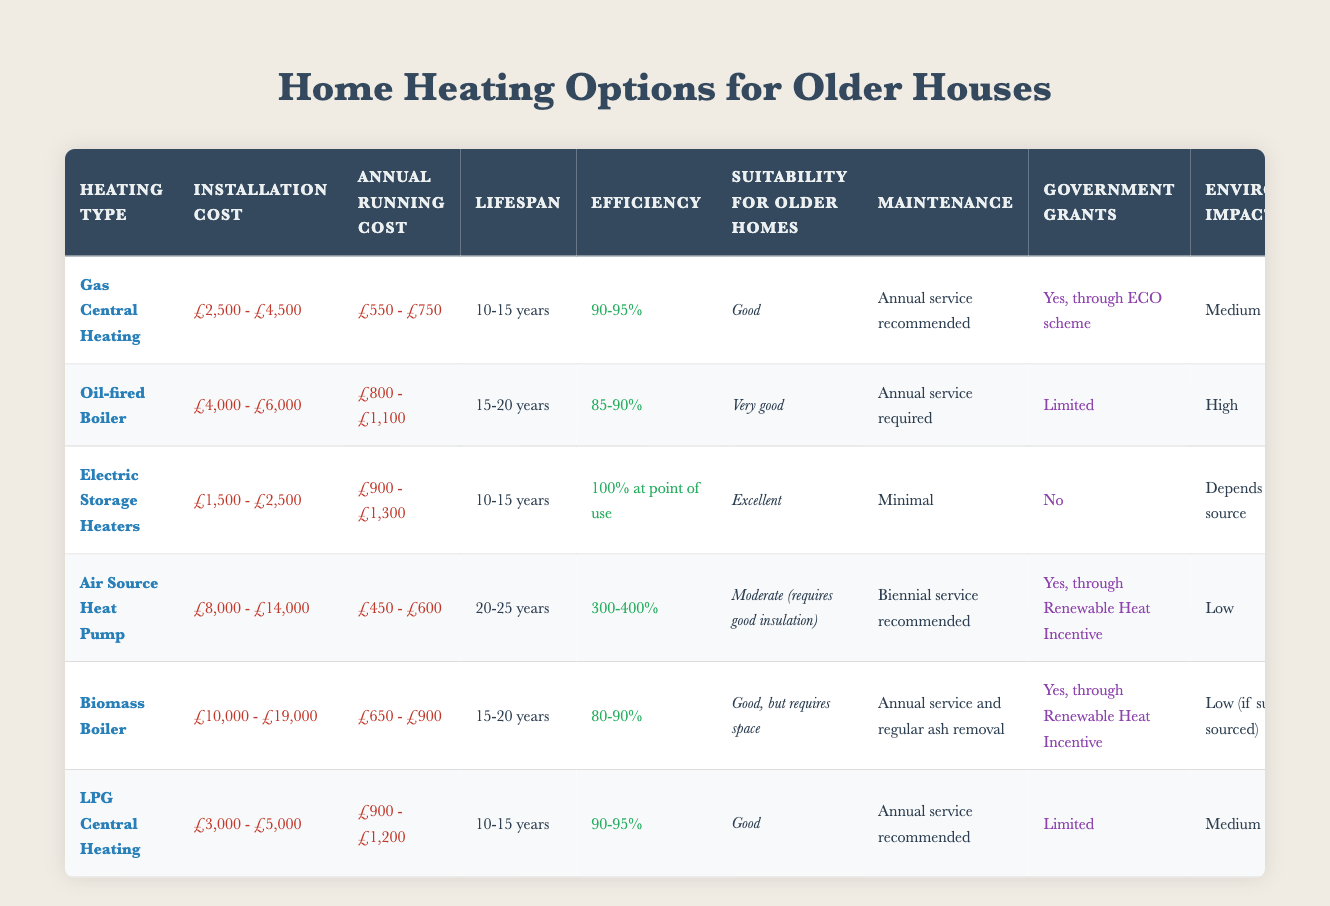What is the installation cost range for Electric Storage Heaters? The table specifies that the installation cost for Electric Storage Heaters is between £1,500 and £2,500.
Answer: £1,500 - £2,500 Which heating option has the longest lifespan? According to the table, the Air Source Heat Pump has a lifespan of 20-25 years, which is the longest among all options listed.
Answer: 20-25 years Does Gas Central Heating have any government grants available? The table states that there are government grants available for Gas Central Heating through the ECO scheme.
Answer: Yes What is the difference in annual running costs between the Oil-fired Boiler and the Gas Central Heating? The annual running cost for Oil-fired Boiler ranges from £800 to £1,100 and for Gas Central Heating ranges from £550 to £750. The difference is calculated as follows: minimum £800 - maximum £750 = £50 (minimum difference) and maximum £1,100 - minimum £550 = £550 (maximum difference). Therefore, the difference in running costs ranges from £50 to £550.
Answer: £50 - £550 Which heating option is the most efficient at point of use? The table shows that Electric Storage Heaters have an efficiency of 100% at point of use, making it the most efficient option listed.
Answer: 100% at point of use Is the environmental impact of an Air Source Heat Pump low? The table indicates that the environmental impact of an Air Source Heat Pump is low, which confirms the statement.
Answer: Yes Which options have minimal maintenance requirements? The table lists Electric Storage Heaters as having minimal maintenance requirements. Additionally, Air Source Heat Pump requires a biennial service, which is also relatively low. Thus, Electric Storage Heaters are the only option explicitly noted for minimal maintenance.
Answer: Electric Storage Heaters What is the average installation cost of all the heating options? To find the average, we need to first summarize each heating option's installation cost by the lower and upper values, then calculate the average. This gives us: (2500+4500+4000+6000+1500+2500+8000+14000+10000+19000+3000+5000) / 6, which gives a total of £11,500 and an average installation cost of £11,500 / 6 = approximately £1,917.
Answer: £1,917 What maintenance is required for the Biomass Boiler? The table specifies that the maintenance for the Biomass Boiler involves an annual service and regular ash removal.
Answer: Annual service and regular ash removal 